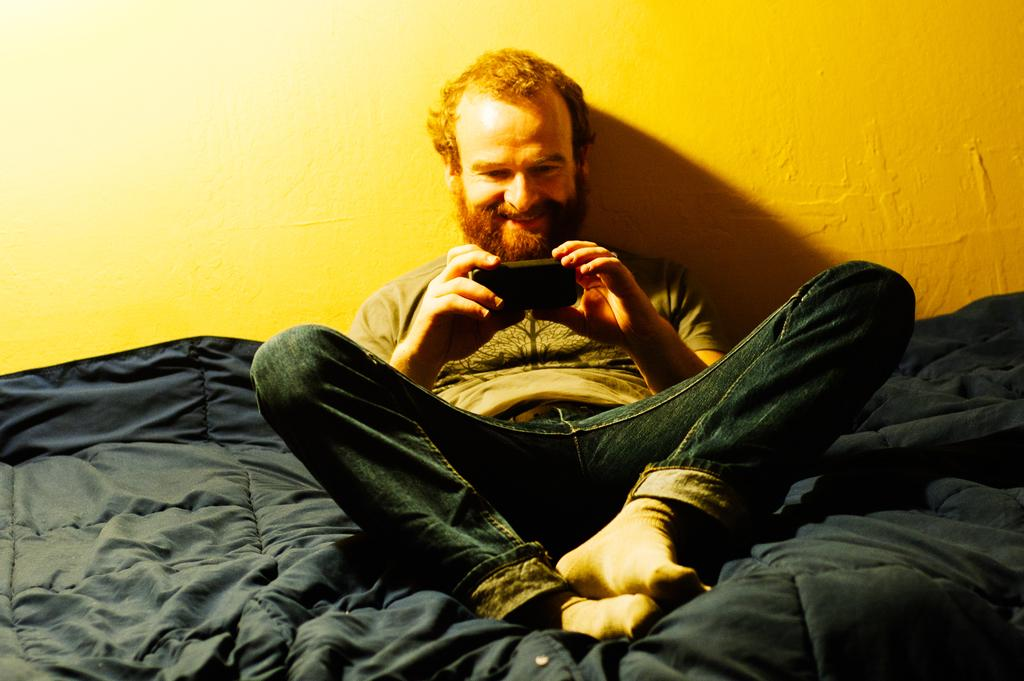What is the main subject of the image? There is a man sitting in the center of the image. What is the man holding in the image? The man is holding a mobile. What can be seen at the bottom of the image? There is a blanket at the bottom of the image. What is visible in the background of the image? There is a wall in the background of the image. Can you see any trees or a river in the image? No, there are no trees or a river visible in the image. 